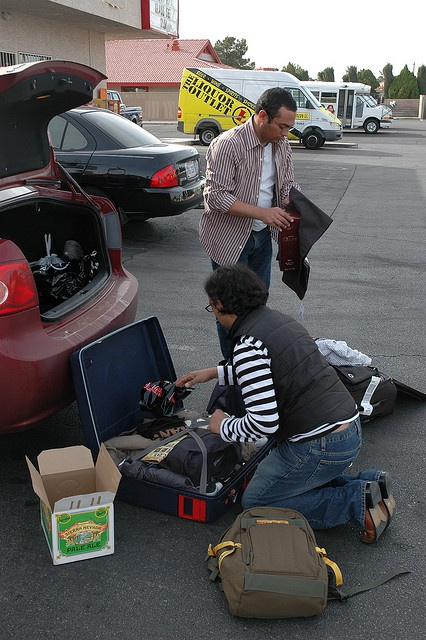Describe the objects in this image and their specific colors. I can see car in gray, black, maroon, and darkgray tones, people in gray, black, navy, and blue tones, suitcase in gray, black, and darkgray tones, people in gray, black, darkgray, and maroon tones, and car in gray, black, darkgray, and darkblue tones in this image. 